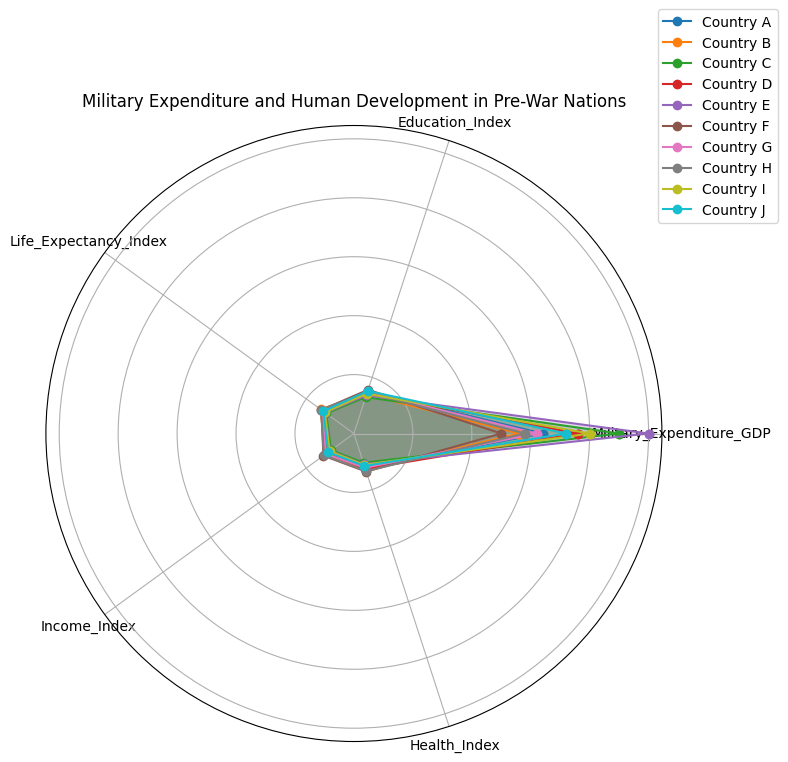Which country has the highest military expenditure as a percentage of GDP? By looking at the radar plot and comparing the values at the 'Military_Expenditure_GDP' axis across all countries, we can identify the country with the highest value.
Answer: Country E Which country shows the highest Education Index? By examining the values at the 'Education_Index' axis, we can determine which country's polygon extends furthest along this axis.
Answer: Country F Among Countries A and B, which one has a higher Life Expectancy Index? Compare the length of the polygons for Countries A and B along the 'Life_Expectancy_Index' axis.
Answer: Country B What is the average Health Index of Countries D, E, and F? Add the Health Index values of Countries D (0.63), E (0.55), and F (0.68) and then divide by 3: (0.63 + 0.55 + 0.68) / 3.
Answer: 0.62 Which country has the most balanced performance across all indices? Look for the country whose polygon appears to be most evenly spread out along all axes, indicating balanced values across all categories.
Answer: Country F Between Countries G and H, which one has a higher Income Index? Look at the positions on the 'Income_Index' axis for Countries G and H and compare their lengths.
Answer: Country H Is there any country with a Life Expectancy Index below 0.60? Check all the countries' positions on the 'Life_Expectancy_Index' axis and identify any values below 0.60.
Answer: Yes, Countries C and E Which two countries have the closest values in Military Expenditure as a percentage of GDP? Compare the polygons on the 'Military_Expenditure_GDP' axis and find the two countries with the most similar values.
Answer: Countries A and G Which country's polygon covers the largest area in total? Visually, the country with the most extensive and broadest polygon indicates the largest overall area.
Answer: Country F What is the difference in the Health Index between the country with the highest and lowest values in this metric? Find the country with the highest Health Index (Country F, 0.68) and the one with the lowest (Country C, 0.52). Subtract the lower value from the higher value: 0.68 - 0.52.
Answer: 0.16 